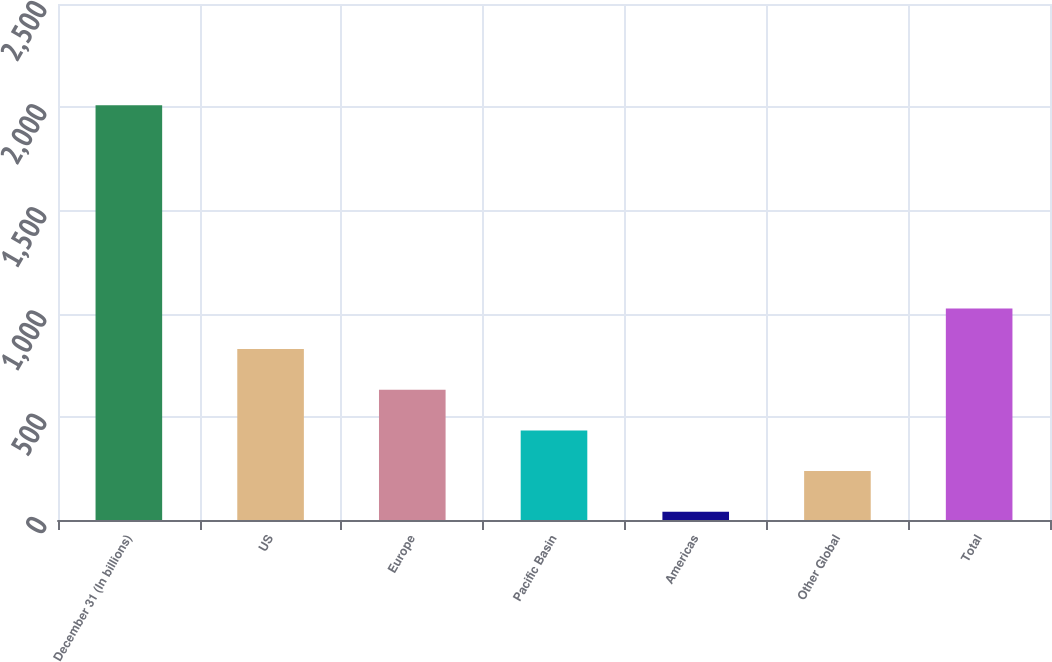Convert chart. <chart><loc_0><loc_0><loc_500><loc_500><bar_chart><fcel>December 31 (In billions)<fcel>US<fcel>Europe<fcel>Pacific Basin<fcel>Americas<fcel>Other Global<fcel>Total<nl><fcel>2010<fcel>828<fcel>631<fcel>434<fcel>40<fcel>237<fcel>1025<nl></chart> 